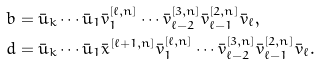Convert formula to latex. <formula><loc_0><loc_0><loc_500><loc_500>b & = \bar { u } _ { k } \cdots \bar { u } _ { 1 } \bar { v } _ { 1 } ^ { [ \ell , n ] } \cdots \bar { v } _ { \ell - 2 } ^ { [ 3 , n ] } \bar { v } _ { \ell - 1 } ^ { [ 2 , n ] } \bar { v } _ { \ell } , \\ d & = \bar { u } _ { k } \cdots \bar { u } _ { 1 } \bar { x } ^ { [ \ell + 1 , n ] } \bar { v } _ { 1 } ^ { [ \ell , n ] } \cdots \bar { v } _ { \ell - 2 } ^ { [ 3 , n ] } \bar { v } _ { \ell - 1 } ^ { [ 2 , n ] } \bar { v } _ { \ell } .</formula> 